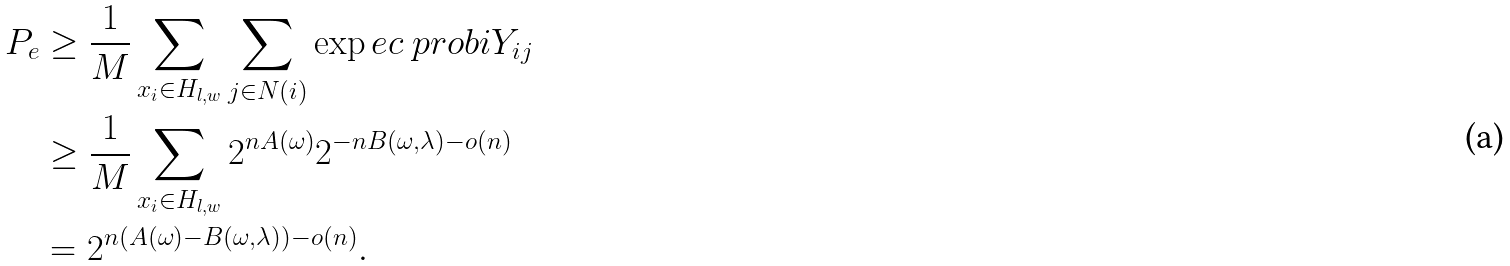<formula> <loc_0><loc_0><loc_500><loc_500>P _ { e } & \geq \frac { 1 } { M } \sum _ { x _ { i } \in H _ { l , w } } \sum _ { j \in N ( i ) } \exp e c { \ p r o b i { Y _ { i j } } } \\ & \geq \frac { 1 } { M } \sum _ { x _ { i } \in H _ { l , w } } 2 ^ { n A ( \omega ) } 2 ^ { - n B ( \omega , \lambda ) - o ( n ) } \\ & = 2 ^ { n ( A ( \omega ) - B ( \omega , \lambda ) ) - o ( n ) } .</formula> 